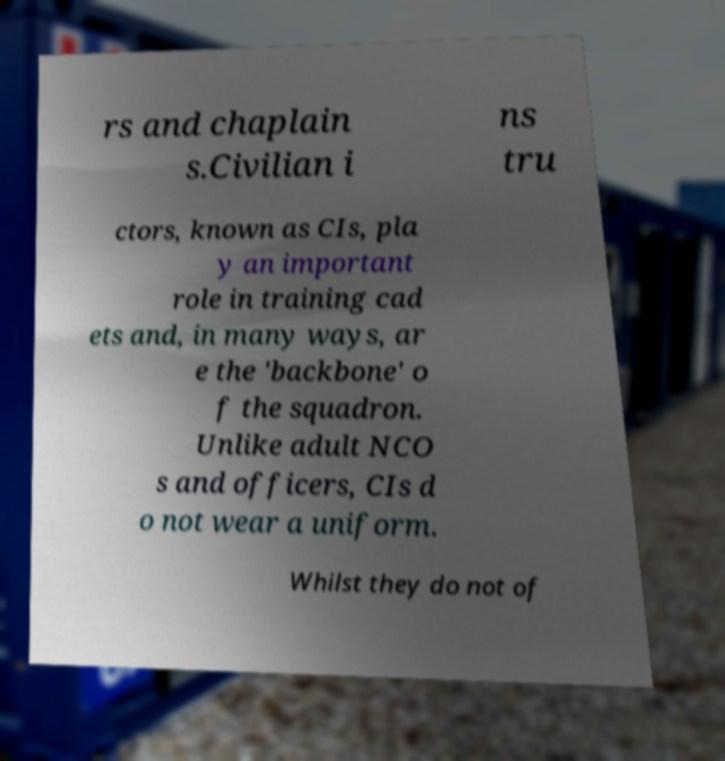Could you assist in decoding the text presented in this image and type it out clearly? rs and chaplain s.Civilian i ns tru ctors, known as CIs, pla y an important role in training cad ets and, in many ways, ar e the 'backbone' o f the squadron. Unlike adult NCO s and officers, CIs d o not wear a uniform. Whilst they do not of 